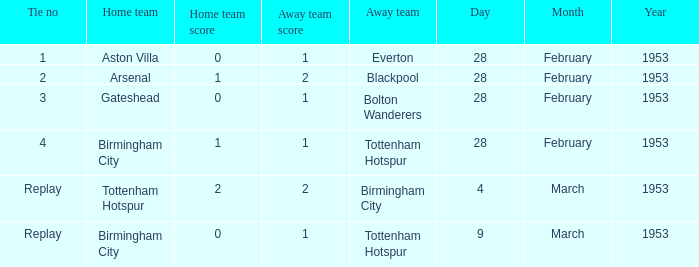Parse the table in full. {'header': ['Tie no', 'Home team', 'Home team score', 'Away team score', 'Away team', 'Day', 'Month', 'Year'], 'rows': [['1', 'Aston Villa', '0', '1', 'Everton', '28', 'February', '1953'], ['2', 'Arsenal', '1', '2', 'Blackpool', '28', 'February', '1953'], ['3', 'Gateshead', '0', '1', 'Bolton Wanderers', '28', 'February', '1953'], ['4', 'Birmingham City', '1', '1', 'Tottenham Hotspur', '28', 'February', '1953'], ['Replay', 'Tottenham Hotspur', '2', '2', 'Birmingham City', '4', 'March', '1953'], ['Replay', 'Birmingham City', '0', '1', 'Tottenham Hotspur', '9', 'March', '1953']]} For which tie on march 9, 1953, was the score 0-1? Replay. 